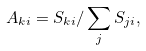<formula> <loc_0><loc_0><loc_500><loc_500>A _ { k i } = S _ { k i } / \sum _ { j } { S _ { j i } } ,</formula> 